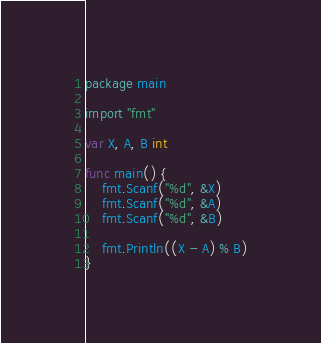<code> <loc_0><loc_0><loc_500><loc_500><_Go_>package main
 
import "fmt"
 
var X, A, B int
 
func main() {
	fmt.Scanf("%d", &X)
	fmt.Scanf("%d", &A)
	fmt.Scanf("%d", &B)
 
	fmt.Println((X - A) % B)
}</code> 